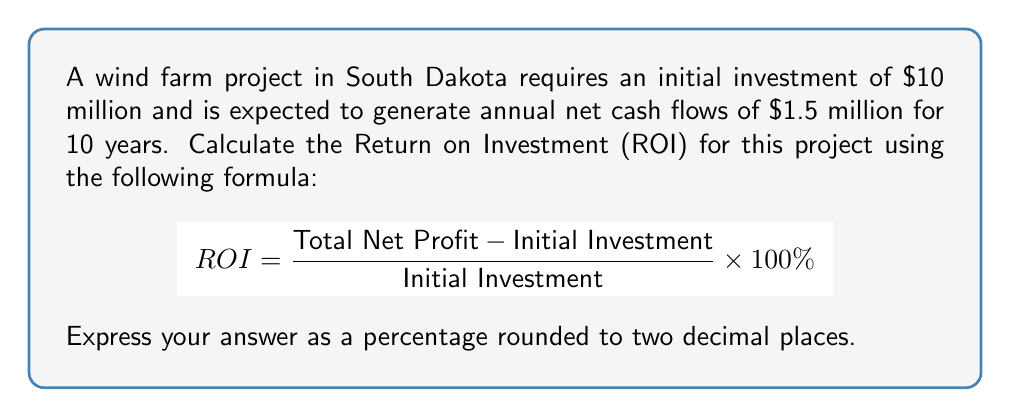Give your solution to this math problem. To solve this problem, we need to follow these steps:

1. Calculate the Total Net Profit:
   Annual net cash flow = $1.5 million
   Project duration = 10 years
   Total Net Profit = $1.5 million × 10 = $15 million

2. Apply the ROI formula:
   $$ ROI = \frac{\text{Total Net Profit} - \text{Initial Investment}}{\text{Initial Investment}} \times 100\% $$
   $$ ROI = \frac{$15,000,000 - $10,000,000}{$10,000,000} \times 100\% $$
   $$ ROI = \frac{$5,000,000}{$10,000,000} \times 100\% $$
   $$ ROI = 0.5 \times 100\% $$
   $$ ROI = 50\% $$

3. The ROI is already expressed as a percentage and rounded to two decimal places, so no further adjustment is needed.
Answer: 50.00% 